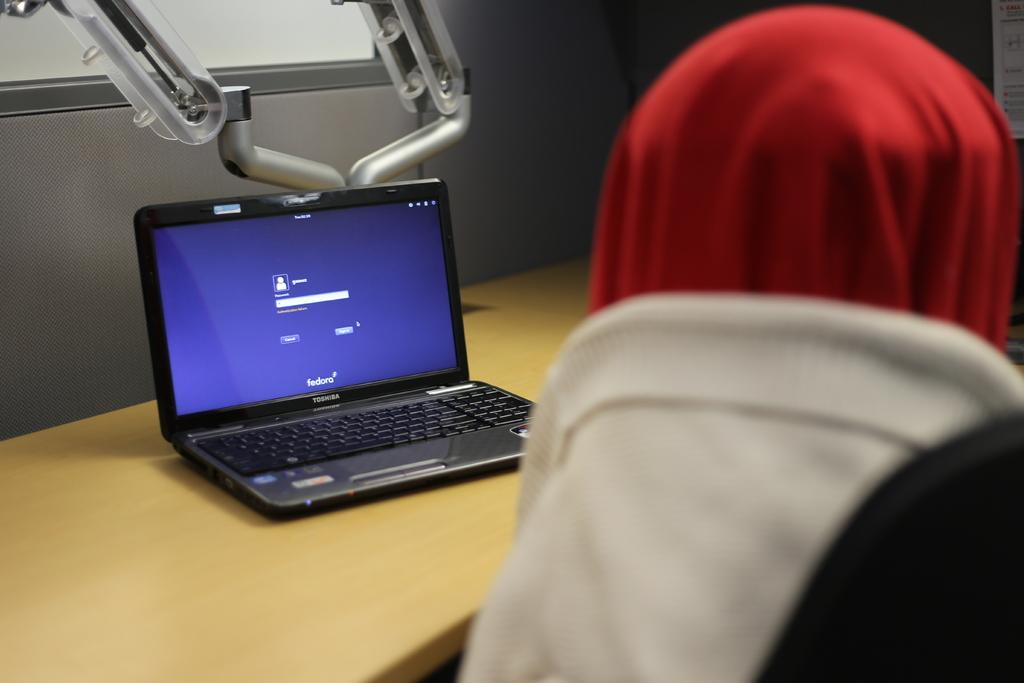What electronic device is visible in the image? There is a laptop in the image. Can you describe the object with red and white colors in the image? Unfortunately, the provided facts do not give enough information to describe the object with red and white colors. How many trains can be seen passing by in the image? There is no mention of trains or any transportation in the image, so it is not possible to answer that question. 